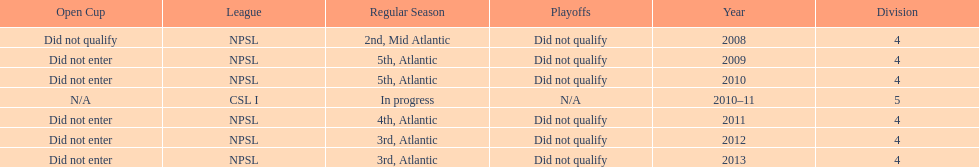What is the singular year that is n/a? 2010-11. 